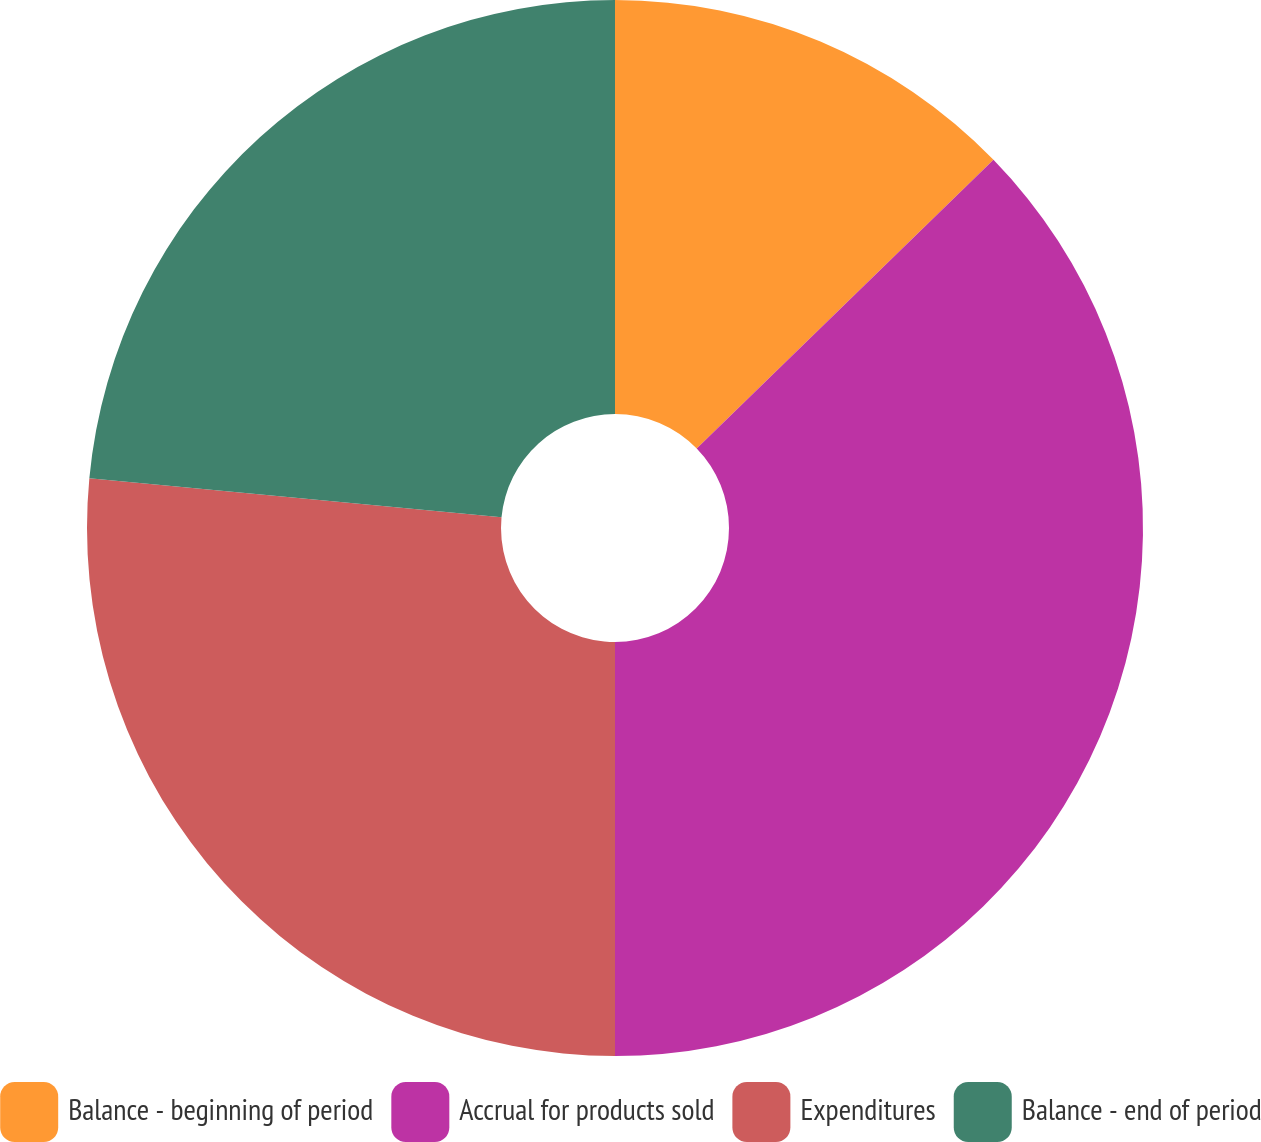Convert chart. <chart><loc_0><loc_0><loc_500><loc_500><pie_chart><fcel>Balance - beginning of period<fcel>Accrual for products sold<fcel>Expenditures<fcel>Balance - end of period<nl><fcel>12.72%<fcel>37.28%<fcel>26.5%<fcel>23.5%<nl></chart> 